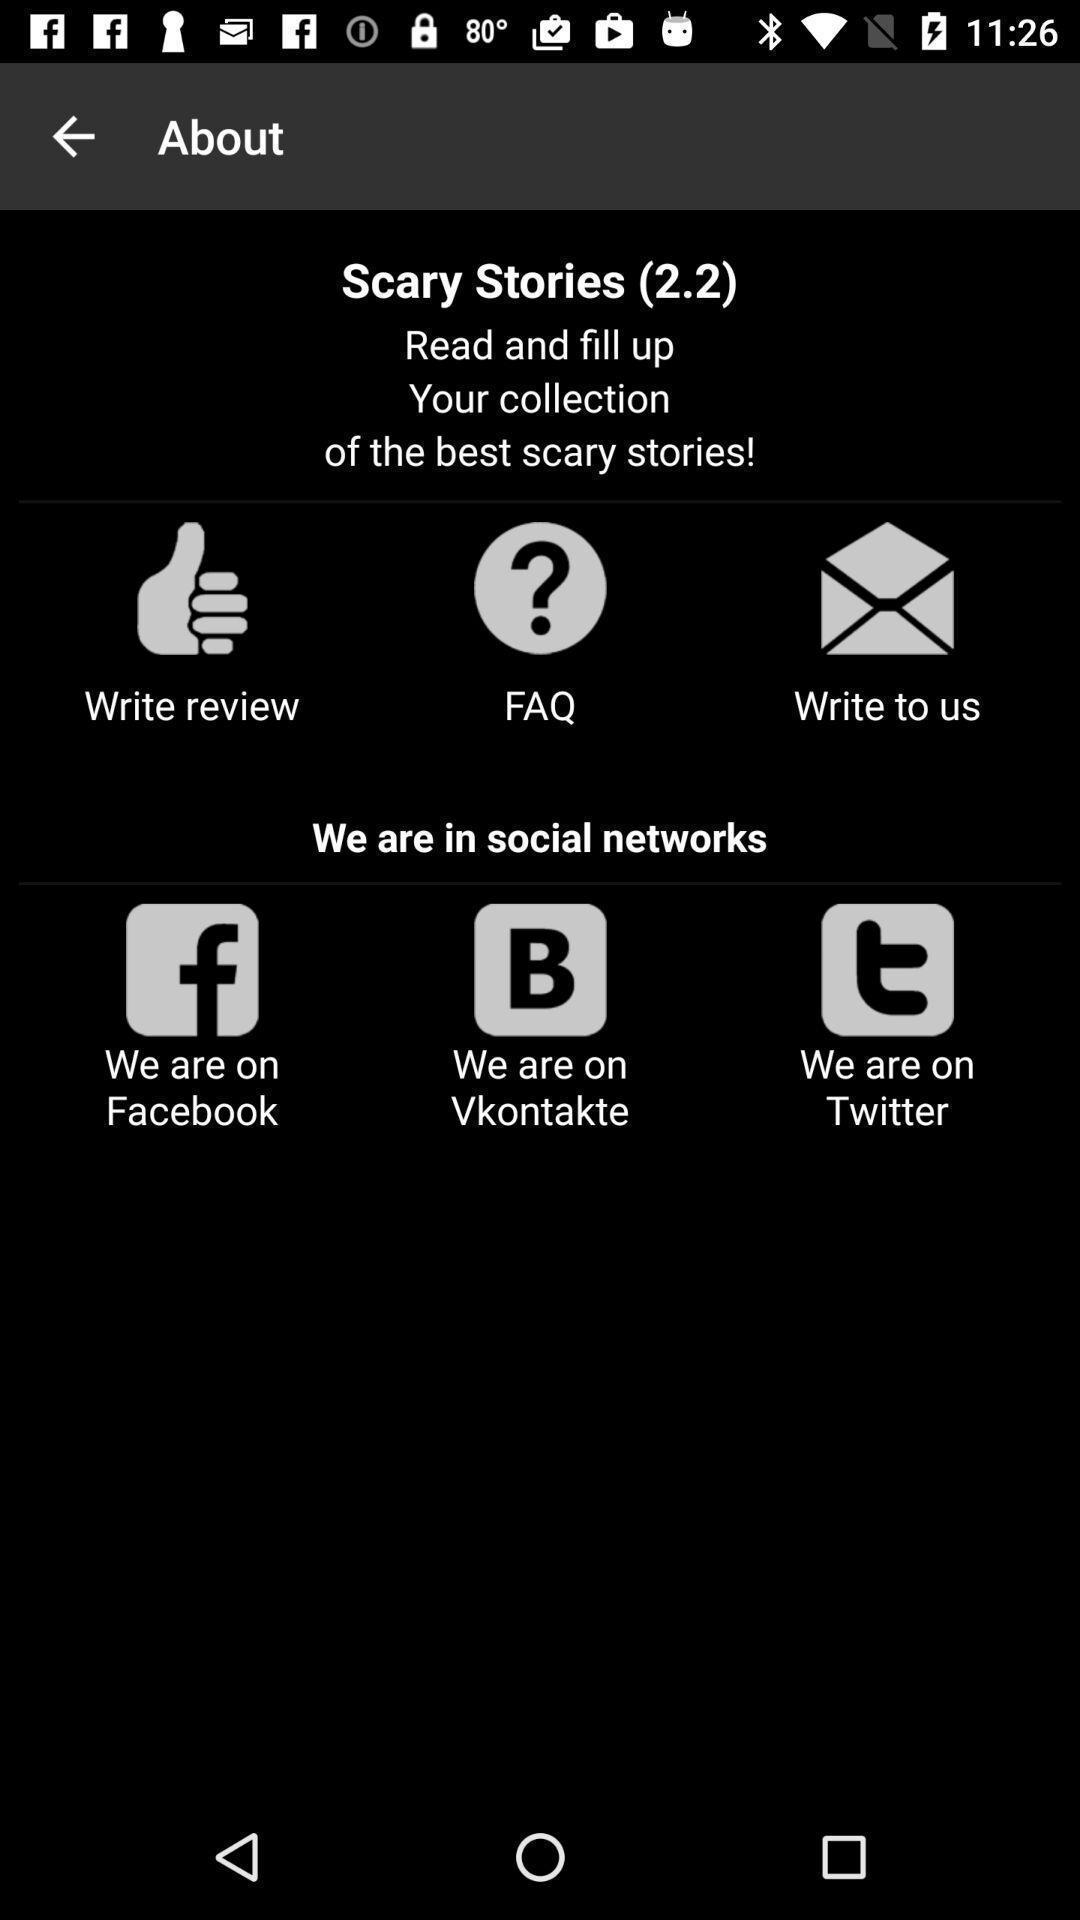Summarize the information in this screenshot. Screen shows information about stories app. 